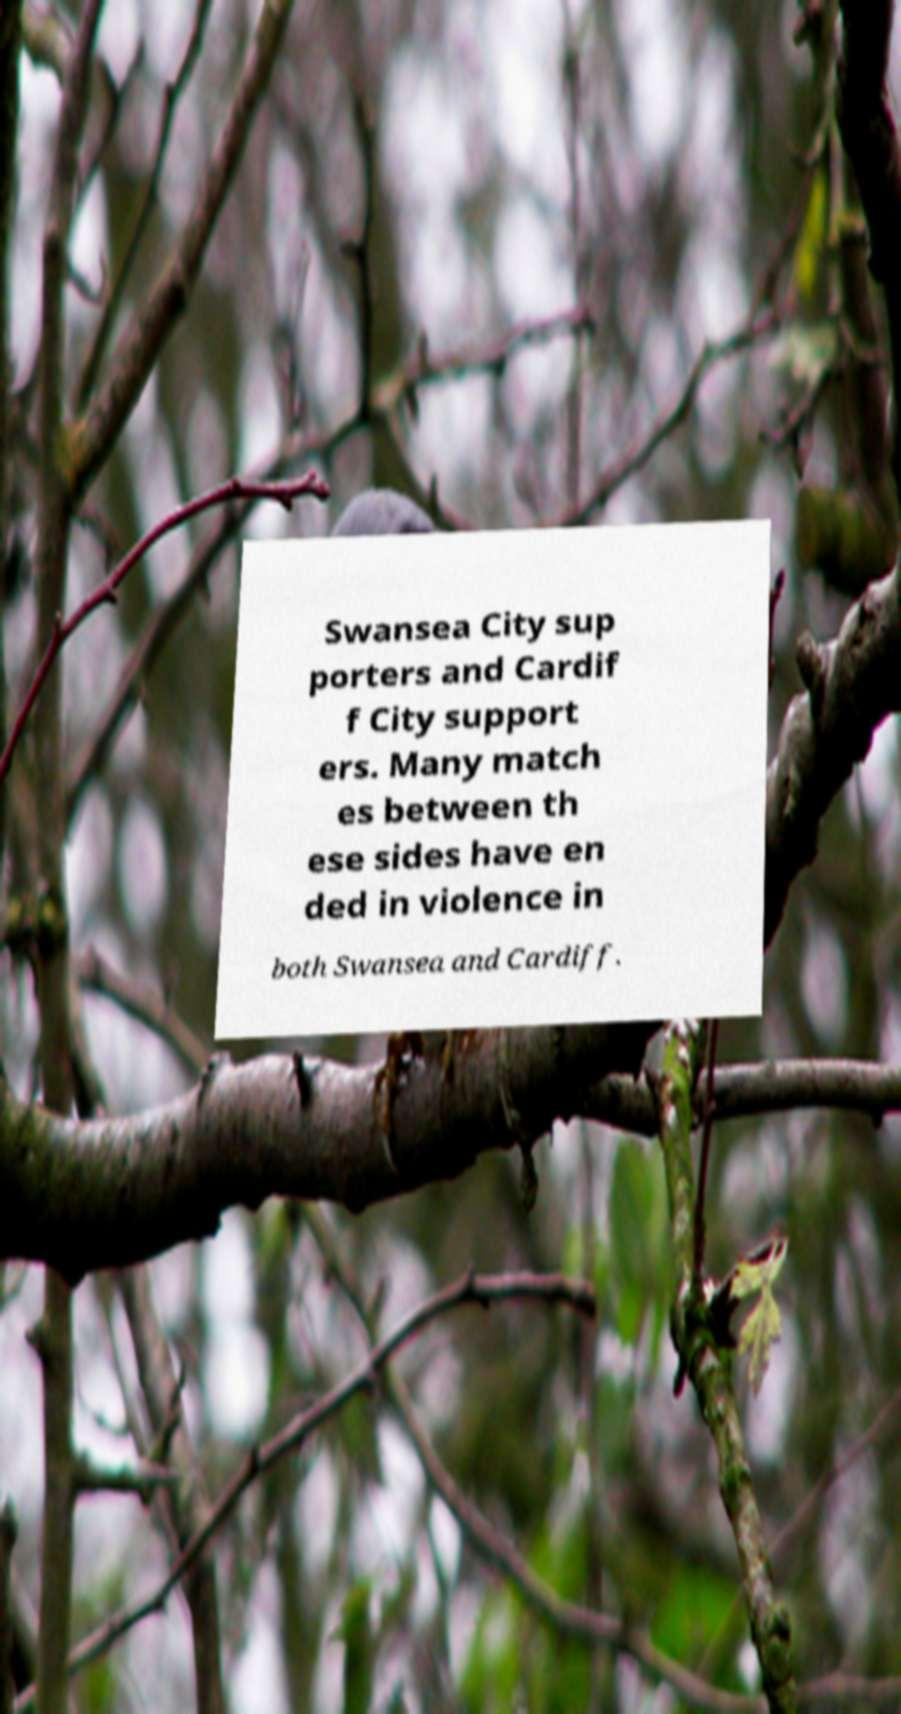For documentation purposes, I need the text within this image transcribed. Could you provide that? Swansea City sup porters and Cardif f City support ers. Many match es between th ese sides have en ded in violence in both Swansea and Cardiff. 